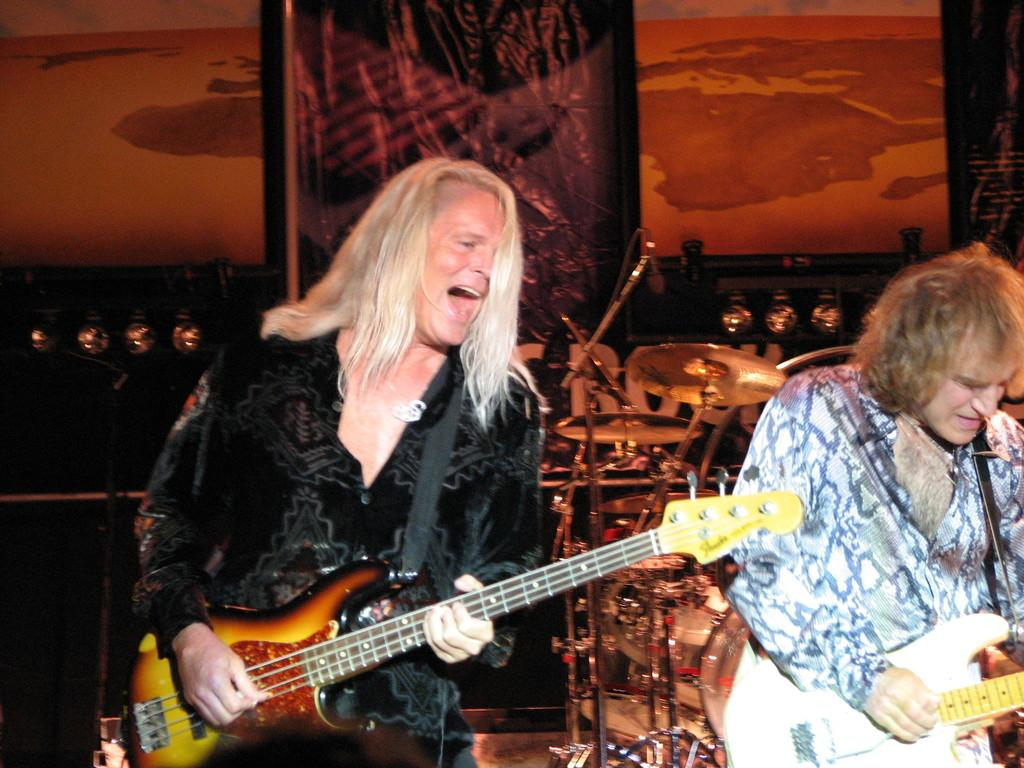What is the man in the image doing? The man is singing in the image. What is the man wearing in the image? The man is wearing a guitar in the image. Can you describe the other person in the image? The other person is also playing a guitar in the image. What else can be seen in the image besides the people? There are musical instruments in the image. What is the value of the engine in the image? There is no engine present in the image. How does the van contribute to the musical performance in the image? There is no van present in the image. 